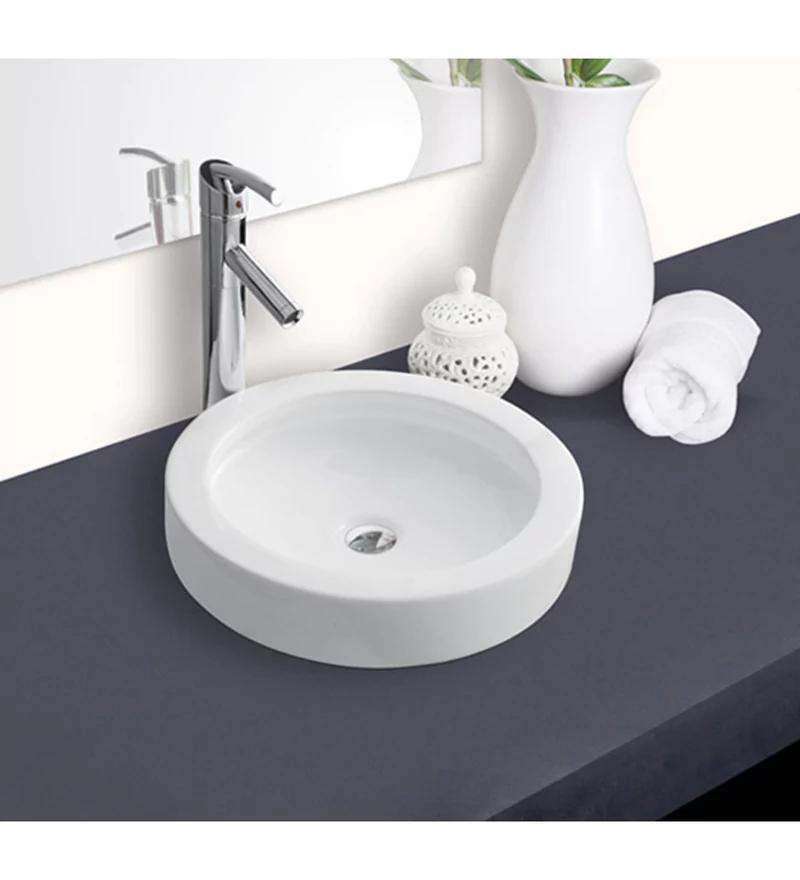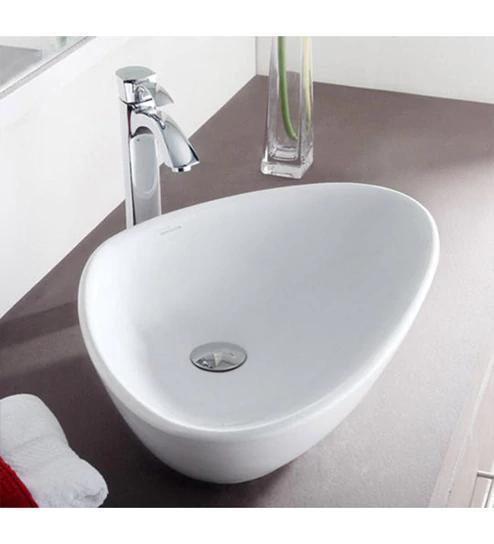The first image is the image on the left, the second image is the image on the right. Analyze the images presented: Is the assertion "In one of the images there is a vase with yellow flowers placed on a counter next to a sink." valid? Answer yes or no. No. 